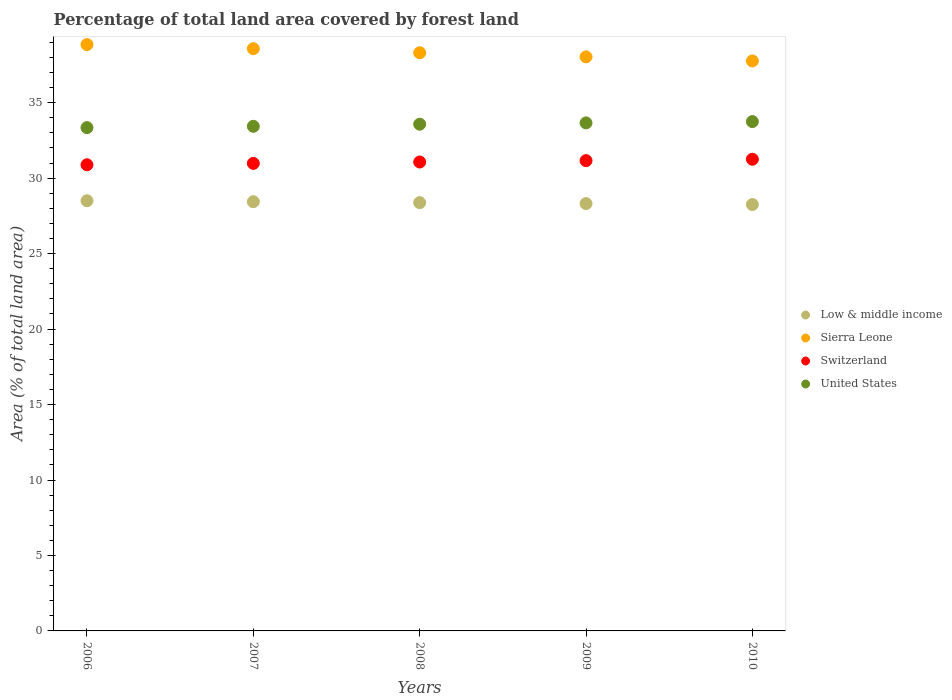How many different coloured dotlines are there?
Provide a succinct answer. 4. Is the number of dotlines equal to the number of legend labels?
Offer a terse response. Yes. What is the percentage of forest land in United States in 2009?
Your answer should be compact. 33.66. Across all years, what is the maximum percentage of forest land in Switzerland?
Your answer should be compact. 31.25. Across all years, what is the minimum percentage of forest land in Sierra Leone?
Provide a succinct answer. 37.77. In which year was the percentage of forest land in Sierra Leone maximum?
Your answer should be compact. 2006. What is the total percentage of forest land in Low & middle income in the graph?
Offer a terse response. 141.89. What is the difference between the percentage of forest land in Sierra Leone in 2007 and that in 2010?
Provide a short and direct response. 0.81. What is the difference between the percentage of forest land in Low & middle income in 2006 and the percentage of forest land in United States in 2007?
Your response must be concise. -4.93. What is the average percentage of forest land in United States per year?
Your response must be concise. 33.55. In the year 2009, what is the difference between the percentage of forest land in Switzerland and percentage of forest land in Sierra Leone?
Your response must be concise. -6.88. What is the ratio of the percentage of forest land in United States in 2009 to that in 2010?
Your answer should be compact. 1. Is the percentage of forest land in Low & middle income in 2007 less than that in 2008?
Your response must be concise. No. Is the difference between the percentage of forest land in Switzerland in 2007 and 2009 greater than the difference between the percentage of forest land in Sierra Leone in 2007 and 2009?
Keep it short and to the point. No. What is the difference between the highest and the second highest percentage of forest land in Switzerland?
Your response must be concise. 0.09. What is the difference between the highest and the lowest percentage of forest land in Sierra Leone?
Provide a short and direct response. 1.09. In how many years, is the percentage of forest land in United States greater than the average percentage of forest land in United States taken over all years?
Keep it short and to the point. 3. Is it the case that in every year, the sum of the percentage of forest land in Sierra Leone and percentage of forest land in United States  is greater than the sum of percentage of forest land in Low & middle income and percentage of forest land in Switzerland?
Make the answer very short. No. Is it the case that in every year, the sum of the percentage of forest land in Low & middle income and percentage of forest land in Switzerland  is greater than the percentage of forest land in United States?
Provide a succinct answer. Yes. Is the percentage of forest land in Low & middle income strictly less than the percentage of forest land in Switzerland over the years?
Offer a terse response. Yes. How many dotlines are there?
Give a very brief answer. 4. How many years are there in the graph?
Your response must be concise. 5. What is the difference between two consecutive major ticks on the Y-axis?
Make the answer very short. 5. Does the graph contain grids?
Give a very brief answer. No. How many legend labels are there?
Provide a short and direct response. 4. How are the legend labels stacked?
Your response must be concise. Vertical. What is the title of the graph?
Your answer should be compact. Percentage of total land area covered by forest land. What is the label or title of the Y-axis?
Ensure brevity in your answer.  Area (% of total land area). What is the Area (% of total land area) of Low & middle income in 2006?
Offer a very short reply. 28.5. What is the Area (% of total land area) in Sierra Leone in 2006?
Keep it short and to the point. 38.85. What is the Area (% of total land area) in Switzerland in 2006?
Give a very brief answer. 30.89. What is the Area (% of total land area) in United States in 2006?
Keep it short and to the point. 33.35. What is the Area (% of total land area) in Low & middle income in 2007?
Give a very brief answer. 28.44. What is the Area (% of total land area) of Sierra Leone in 2007?
Make the answer very short. 38.58. What is the Area (% of total land area) in Switzerland in 2007?
Offer a terse response. 30.98. What is the Area (% of total land area) of United States in 2007?
Provide a succinct answer. 33.44. What is the Area (% of total land area) of Low & middle income in 2008?
Ensure brevity in your answer.  28.38. What is the Area (% of total land area) of Sierra Leone in 2008?
Your response must be concise. 38.31. What is the Area (% of total land area) of Switzerland in 2008?
Make the answer very short. 31.07. What is the Area (% of total land area) of United States in 2008?
Keep it short and to the point. 33.58. What is the Area (% of total land area) of Low & middle income in 2009?
Your answer should be very brief. 28.32. What is the Area (% of total land area) of Sierra Leone in 2009?
Offer a terse response. 38.04. What is the Area (% of total land area) of Switzerland in 2009?
Ensure brevity in your answer.  31.16. What is the Area (% of total land area) in United States in 2009?
Ensure brevity in your answer.  33.66. What is the Area (% of total land area) in Low & middle income in 2010?
Your answer should be very brief. 28.25. What is the Area (% of total land area) of Sierra Leone in 2010?
Your answer should be compact. 37.77. What is the Area (% of total land area) of Switzerland in 2010?
Offer a very short reply. 31.25. What is the Area (% of total land area) of United States in 2010?
Ensure brevity in your answer.  33.75. Across all years, what is the maximum Area (% of total land area) in Low & middle income?
Offer a very short reply. 28.5. Across all years, what is the maximum Area (% of total land area) in Sierra Leone?
Your response must be concise. 38.85. Across all years, what is the maximum Area (% of total land area) of Switzerland?
Give a very brief answer. 31.25. Across all years, what is the maximum Area (% of total land area) of United States?
Your answer should be very brief. 33.75. Across all years, what is the minimum Area (% of total land area) in Low & middle income?
Offer a terse response. 28.25. Across all years, what is the minimum Area (% of total land area) in Sierra Leone?
Your answer should be very brief. 37.77. Across all years, what is the minimum Area (% of total land area) in Switzerland?
Your answer should be compact. 30.89. Across all years, what is the minimum Area (% of total land area) of United States?
Ensure brevity in your answer.  33.35. What is the total Area (% of total land area) in Low & middle income in the graph?
Provide a succinct answer. 141.89. What is the total Area (% of total land area) in Sierra Leone in the graph?
Provide a short and direct response. 191.55. What is the total Area (% of total land area) in Switzerland in the graph?
Keep it short and to the point. 155.35. What is the total Area (% of total land area) in United States in the graph?
Offer a terse response. 167.77. What is the difference between the Area (% of total land area) in Low & middle income in 2006 and that in 2007?
Keep it short and to the point. 0.06. What is the difference between the Area (% of total land area) in Sierra Leone in 2006 and that in 2007?
Provide a succinct answer. 0.27. What is the difference between the Area (% of total land area) in Switzerland in 2006 and that in 2007?
Offer a very short reply. -0.09. What is the difference between the Area (% of total land area) of United States in 2006 and that in 2007?
Provide a short and direct response. -0.09. What is the difference between the Area (% of total land area) of Low & middle income in 2006 and that in 2008?
Your answer should be compact. 0.13. What is the difference between the Area (% of total land area) of Sierra Leone in 2006 and that in 2008?
Keep it short and to the point. 0.54. What is the difference between the Area (% of total land area) of Switzerland in 2006 and that in 2008?
Your answer should be compact. -0.18. What is the difference between the Area (% of total land area) of United States in 2006 and that in 2008?
Your answer should be compact. -0.23. What is the difference between the Area (% of total land area) in Low & middle income in 2006 and that in 2009?
Ensure brevity in your answer.  0.19. What is the difference between the Area (% of total land area) of Sierra Leone in 2006 and that in 2009?
Give a very brief answer. 0.81. What is the difference between the Area (% of total land area) of Switzerland in 2006 and that in 2009?
Make the answer very short. -0.27. What is the difference between the Area (% of total land area) in United States in 2006 and that in 2009?
Make the answer very short. -0.31. What is the difference between the Area (% of total land area) in Low & middle income in 2006 and that in 2010?
Make the answer very short. 0.25. What is the difference between the Area (% of total land area) of Sierra Leone in 2006 and that in 2010?
Provide a short and direct response. 1.09. What is the difference between the Area (% of total land area) of Switzerland in 2006 and that in 2010?
Make the answer very short. -0.37. What is the difference between the Area (% of total land area) in United States in 2006 and that in 2010?
Your response must be concise. -0.4. What is the difference between the Area (% of total land area) of Low & middle income in 2007 and that in 2008?
Provide a succinct answer. 0.06. What is the difference between the Area (% of total land area) of Sierra Leone in 2007 and that in 2008?
Provide a succinct answer. 0.27. What is the difference between the Area (% of total land area) of Switzerland in 2007 and that in 2008?
Make the answer very short. -0.09. What is the difference between the Area (% of total land area) of United States in 2007 and that in 2008?
Your answer should be very brief. -0.14. What is the difference between the Area (% of total land area) of Low & middle income in 2007 and that in 2009?
Your answer should be very brief. 0.12. What is the difference between the Area (% of total land area) in Sierra Leone in 2007 and that in 2009?
Give a very brief answer. 0.54. What is the difference between the Area (% of total land area) in Switzerland in 2007 and that in 2009?
Keep it short and to the point. -0.18. What is the difference between the Area (% of total land area) of United States in 2007 and that in 2009?
Provide a short and direct response. -0.23. What is the difference between the Area (% of total land area) in Low & middle income in 2007 and that in 2010?
Your answer should be compact. 0.19. What is the difference between the Area (% of total land area) of Sierra Leone in 2007 and that in 2010?
Ensure brevity in your answer.  0.81. What is the difference between the Area (% of total land area) in Switzerland in 2007 and that in 2010?
Your response must be concise. -0.27. What is the difference between the Area (% of total land area) of United States in 2007 and that in 2010?
Provide a short and direct response. -0.31. What is the difference between the Area (% of total land area) of Low & middle income in 2008 and that in 2009?
Make the answer very short. 0.06. What is the difference between the Area (% of total land area) in Sierra Leone in 2008 and that in 2009?
Keep it short and to the point. 0.27. What is the difference between the Area (% of total land area) of Switzerland in 2008 and that in 2009?
Ensure brevity in your answer.  -0.09. What is the difference between the Area (% of total land area) of United States in 2008 and that in 2009?
Offer a terse response. -0.09. What is the difference between the Area (% of total land area) of Low & middle income in 2008 and that in 2010?
Provide a succinct answer. 0.13. What is the difference between the Area (% of total land area) of Sierra Leone in 2008 and that in 2010?
Keep it short and to the point. 0.54. What is the difference between the Area (% of total land area) in Switzerland in 2008 and that in 2010?
Provide a short and direct response. -0.18. What is the difference between the Area (% of total land area) of United States in 2008 and that in 2010?
Provide a succinct answer. -0.17. What is the difference between the Area (% of total land area) in Low & middle income in 2009 and that in 2010?
Your response must be concise. 0.06. What is the difference between the Area (% of total land area) of Sierra Leone in 2009 and that in 2010?
Ensure brevity in your answer.  0.27. What is the difference between the Area (% of total land area) in Switzerland in 2009 and that in 2010?
Your answer should be compact. -0.09. What is the difference between the Area (% of total land area) of United States in 2009 and that in 2010?
Your answer should be compact. -0.09. What is the difference between the Area (% of total land area) of Low & middle income in 2006 and the Area (% of total land area) of Sierra Leone in 2007?
Ensure brevity in your answer.  -10.08. What is the difference between the Area (% of total land area) of Low & middle income in 2006 and the Area (% of total land area) of Switzerland in 2007?
Ensure brevity in your answer.  -2.48. What is the difference between the Area (% of total land area) in Low & middle income in 2006 and the Area (% of total land area) in United States in 2007?
Provide a short and direct response. -4.93. What is the difference between the Area (% of total land area) of Sierra Leone in 2006 and the Area (% of total land area) of Switzerland in 2007?
Provide a succinct answer. 7.87. What is the difference between the Area (% of total land area) of Sierra Leone in 2006 and the Area (% of total land area) of United States in 2007?
Make the answer very short. 5.42. What is the difference between the Area (% of total land area) of Switzerland in 2006 and the Area (% of total land area) of United States in 2007?
Keep it short and to the point. -2.55. What is the difference between the Area (% of total land area) in Low & middle income in 2006 and the Area (% of total land area) in Sierra Leone in 2008?
Offer a terse response. -9.81. What is the difference between the Area (% of total land area) of Low & middle income in 2006 and the Area (% of total land area) of Switzerland in 2008?
Provide a succinct answer. -2.57. What is the difference between the Area (% of total land area) of Low & middle income in 2006 and the Area (% of total land area) of United States in 2008?
Your answer should be very brief. -5.07. What is the difference between the Area (% of total land area) in Sierra Leone in 2006 and the Area (% of total land area) in Switzerland in 2008?
Provide a short and direct response. 7.78. What is the difference between the Area (% of total land area) of Sierra Leone in 2006 and the Area (% of total land area) of United States in 2008?
Ensure brevity in your answer.  5.28. What is the difference between the Area (% of total land area) of Switzerland in 2006 and the Area (% of total land area) of United States in 2008?
Keep it short and to the point. -2.69. What is the difference between the Area (% of total land area) in Low & middle income in 2006 and the Area (% of total land area) in Sierra Leone in 2009?
Your response must be concise. -9.53. What is the difference between the Area (% of total land area) of Low & middle income in 2006 and the Area (% of total land area) of Switzerland in 2009?
Your response must be concise. -2.66. What is the difference between the Area (% of total land area) of Low & middle income in 2006 and the Area (% of total land area) of United States in 2009?
Give a very brief answer. -5.16. What is the difference between the Area (% of total land area) of Sierra Leone in 2006 and the Area (% of total land area) of Switzerland in 2009?
Your response must be concise. 7.69. What is the difference between the Area (% of total land area) of Sierra Leone in 2006 and the Area (% of total land area) of United States in 2009?
Offer a terse response. 5.19. What is the difference between the Area (% of total land area) of Switzerland in 2006 and the Area (% of total land area) of United States in 2009?
Keep it short and to the point. -2.77. What is the difference between the Area (% of total land area) in Low & middle income in 2006 and the Area (% of total land area) in Sierra Leone in 2010?
Ensure brevity in your answer.  -9.26. What is the difference between the Area (% of total land area) of Low & middle income in 2006 and the Area (% of total land area) of Switzerland in 2010?
Ensure brevity in your answer.  -2.75. What is the difference between the Area (% of total land area) of Low & middle income in 2006 and the Area (% of total land area) of United States in 2010?
Provide a succinct answer. -5.25. What is the difference between the Area (% of total land area) of Sierra Leone in 2006 and the Area (% of total land area) of Switzerland in 2010?
Your response must be concise. 7.6. What is the difference between the Area (% of total land area) in Sierra Leone in 2006 and the Area (% of total land area) in United States in 2010?
Your answer should be compact. 5.1. What is the difference between the Area (% of total land area) of Switzerland in 2006 and the Area (% of total land area) of United States in 2010?
Keep it short and to the point. -2.86. What is the difference between the Area (% of total land area) of Low & middle income in 2007 and the Area (% of total land area) of Sierra Leone in 2008?
Your answer should be compact. -9.87. What is the difference between the Area (% of total land area) in Low & middle income in 2007 and the Area (% of total land area) in Switzerland in 2008?
Ensure brevity in your answer.  -2.63. What is the difference between the Area (% of total land area) in Low & middle income in 2007 and the Area (% of total land area) in United States in 2008?
Your answer should be very brief. -5.13. What is the difference between the Area (% of total land area) in Sierra Leone in 2007 and the Area (% of total land area) in Switzerland in 2008?
Your response must be concise. 7.51. What is the difference between the Area (% of total land area) of Sierra Leone in 2007 and the Area (% of total land area) of United States in 2008?
Provide a succinct answer. 5.01. What is the difference between the Area (% of total land area) in Switzerland in 2007 and the Area (% of total land area) in United States in 2008?
Your response must be concise. -2.6. What is the difference between the Area (% of total land area) in Low & middle income in 2007 and the Area (% of total land area) in Sierra Leone in 2009?
Offer a very short reply. -9.6. What is the difference between the Area (% of total land area) in Low & middle income in 2007 and the Area (% of total land area) in Switzerland in 2009?
Make the answer very short. -2.72. What is the difference between the Area (% of total land area) of Low & middle income in 2007 and the Area (% of total land area) of United States in 2009?
Give a very brief answer. -5.22. What is the difference between the Area (% of total land area) of Sierra Leone in 2007 and the Area (% of total land area) of Switzerland in 2009?
Offer a terse response. 7.42. What is the difference between the Area (% of total land area) in Sierra Leone in 2007 and the Area (% of total land area) in United States in 2009?
Offer a very short reply. 4.92. What is the difference between the Area (% of total land area) of Switzerland in 2007 and the Area (% of total land area) of United States in 2009?
Your answer should be compact. -2.68. What is the difference between the Area (% of total land area) in Low & middle income in 2007 and the Area (% of total land area) in Sierra Leone in 2010?
Offer a very short reply. -9.33. What is the difference between the Area (% of total land area) in Low & middle income in 2007 and the Area (% of total land area) in Switzerland in 2010?
Provide a short and direct response. -2.81. What is the difference between the Area (% of total land area) in Low & middle income in 2007 and the Area (% of total land area) in United States in 2010?
Give a very brief answer. -5.31. What is the difference between the Area (% of total land area) of Sierra Leone in 2007 and the Area (% of total land area) of Switzerland in 2010?
Offer a very short reply. 7.33. What is the difference between the Area (% of total land area) of Sierra Leone in 2007 and the Area (% of total land area) of United States in 2010?
Provide a short and direct response. 4.83. What is the difference between the Area (% of total land area) of Switzerland in 2007 and the Area (% of total land area) of United States in 2010?
Provide a short and direct response. -2.77. What is the difference between the Area (% of total land area) in Low & middle income in 2008 and the Area (% of total land area) in Sierra Leone in 2009?
Give a very brief answer. -9.66. What is the difference between the Area (% of total land area) in Low & middle income in 2008 and the Area (% of total land area) in Switzerland in 2009?
Your answer should be compact. -2.78. What is the difference between the Area (% of total land area) of Low & middle income in 2008 and the Area (% of total land area) of United States in 2009?
Make the answer very short. -5.28. What is the difference between the Area (% of total land area) in Sierra Leone in 2008 and the Area (% of total land area) in Switzerland in 2009?
Offer a terse response. 7.15. What is the difference between the Area (% of total land area) in Sierra Leone in 2008 and the Area (% of total land area) in United States in 2009?
Keep it short and to the point. 4.65. What is the difference between the Area (% of total land area) in Switzerland in 2008 and the Area (% of total land area) in United States in 2009?
Your response must be concise. -2.59. What is the difference between the Area (% of total land area) of Low & middle income in 2008 and the Area (% of total land area) of Sierra Leone in 2010?
Provide a succinct answer. -9.39. What is the difference between the Area (% of total land area) in Low & middle income in 2008 and the Area (% of total land area) in Switzerland in 2010?
Provide a short and direct response. -2.87. What is the difference between the Area (% of total land area) of Low & middle income in 2008 and the Area (% of total land area) of United States in 2010?
Your answer should be very brief. -5.37. What is the difference between the Area (% of total land area) in Sierra Leone in 2008 and the Area (% of total land area) in Switzerland in 2010?
Your answer should be compact. 7.06. What is the difference between the Area (% of total land area) of Sierra Leone in 2008 and the Area (% of total land area) of United States in 2010?
Provide a short and direct response. 4.56. What is the difference between the Area (% of total land area) of Switzerland in 2008 and the Area (% of total land area) of United States in 2010?
Offer a very short reply. -2.68. What is the difference between the Area (% of total land area) of Low & middle income in 2009 and the Area (% of total land area) of Sierra Leone in 2010?
Your answer should be very brief. -9.45. What is the difference between the Area (% of total land area) in Low & middle income in 2009 and the Area (% of total land area) in Switzerland in 2010?
Offer a terse response. -2.94. What is the difference between the Area (% of total land area) of Low & middle income in 2009 and the Area (% of total land area) of United States in 2010?
Offer a very short reply. -5.43. What is the difference between the Area (% of total land area) of Sierra Leone in 2009 and the Area (% of total land area) of Switzerland in 2010?
Keep it short and to the point. 6.79. What is the difference between the Area (% of total land area) in Sierra Leone in 2009 and the Area (% of total land area) in United States in 2010?
Your answer should be very brief. 4.29. What is the difference between the Area (% of total land area) of Switzerland in 2009 and the Area (% of total land area) of United States in 2010?
Give a very brief answer. -2.59. What is the average Area (% of total land area) in Low & middle income per year?
Provide a succinct answer. 28.38. What is the average Area (% of total land area) in Sierra Leone per year?
Ensure brevity in your answer.  38.31. What is the average Area (% of total land area) of Switzerland per year?
Your response must be concise. 31.07. What is the average Area (% of total land area) of United States per year?
Your answer should be compact. 33.55. In the year 2006, what is the difference between the Area (% of total land area) of Low & middle income and Area (% of total land area) of Sierra Leone?
Give a very brief answer. -10.35. In the year 2006, what is the difference between the Area (% of total land area) in Low & middle income and Area (% of total land area) in Switzerland?
Provide a short and direct response. -2.38. In the year 2006, what is the difference between the Area (% of total land area) of Low & middle income and Area (% of total land area) of United States?
Your response must be concise. -4.85. In the year 2006, what is the difference between the Area (% of total land area) in Sierra Leone and Area (% of total land area) in Switzerland?
Offer a very short reply. 7.96. In the year 2006, what is the difference between the Area (% of total land area) in Sierra Leone and Area (% of total land area) in United States?
Provide a short and direct response. 5.5. In the year 2006, what is the difference between the Area (% of total land area) in Switzerland and Area (% of total land area) in United States?
Provide a succinct answer. -2.46. In the year 2007, what is the difference between the Area (% of total land area) in Low & middle income and Area (% of total land area) in Sierra Leone?
Provide a short and direct response. -10.14. In the year 2007, what is the difference between the Area (% of total land area) of Low & middle income and Area (% of total land area) of Switzerland?
Ensure brevity in your answer.  -2.54. In the year 2007, what is the difference between the Area (% of total land area) in Low & middle income and Area (% of total land area) in United States?
Your answer should be very brief. -5. In the year 2007, what is the difference between the Area (% of total land area) of Sierra Leone and Area (% of total land area) of Switzerland?
Provide a short and direct response. 7.6. In the year 2007, what is the difference between the Area (% of total land area) in Sierra Leone and Area (% of total land area) in United States?
Offer a terse response. 5.14. In the year 2007, what is the difference between the Area (% of total land area) of Switzerland and Area (% of total land area) of United States?
Provide a short and direct response. -2.46. In the year 2008, what is the difference between the Area (% of total land area) of Low & middle income and Area (% of total land area) of Sierra Leone?
Keep it short and to the point. -9.93. In the year 2008, what is the difference between the Area (% of total land area) of Low & middle income and Area (% of total land area) of Switzerland?
Your answer should be very brief. -2.69. In the year 2008, what is the difference between the Area (% of total land area) in Low & middle income and Area (% of total land area) in United States?
Your response must be concise. -5.2. In the year 2008, what is the difference between the Area (% of total land area) of Sierra Leone and Area (% of total land area) of Switzerland?
Offer a terse response. 7.24. In the year 2008, what is the difference between the Area (% of total land area) in Sierra Leone and Area (% of total land area) in United States?
Make the answer very short. 4.73. In the year 2008, what is the difference between the Area (% of total land area) of Switzerland and Area (% of total land area) of United States?
Your response must be concise. -2.51. In the year 2009, what is the difference between the Area (% of total land area) in Low & middle income and Area (% of total land area) in Sierra Leone?
Your response must be concise. -9.72. In the year 2009, what is the difference between the Area (% of total land area) in Low & middle income and Area (% of total land area) in Switzerland?
Your response must be concise. -2.85. In the year 2009, what is the difference between the Area (% of total land area) in Low & middle income and Area (% of total land area) in United States?
Keep it short and to the point. -5.35. In the year 2009, what is the difference between the Area (% of total land area) of Sierra Leone and Area (% of total land area) of Switzerland?
Offer a terse response. 6.88. In the year 2009, what is the difference between the Area (% of total land area) of Sierra Leone and Area (% of total land area) of United States?
Offer a very short reply. 4.38. In the year 2009, what is the difference between the Area (% of total land area) in Switzerland and Area (% of total land area) in United States?
Your answer should be compact. -2.5. In the year 2010, what is the difference between the Area (% of total land area) in Low & middle income and Area (% of total land area) in Sierra Leone?
Provide a short and direct response. -9.51. In the year 2010, what is the difference between the Area (% of total land area) of Low & middle income and Area (% of total land area) of Switzerland?
Provide a succinct answer. -3. In the year 2010, what is the difference between the Area (% of total land area) of Low & middle income and Area (% of total land area) of United States?
Provide a short and direct response. -5.5. In the year 2010, what is the difference between the Area (% of total land area) of Sierra Leone and Area (% of total land area) of Switzerland?
Your answer should be very brief. 6.51. In the year 2010, what is the difference between the Area (% of total land area) of Sierra Leone and Area (% of total land area) of United States?
Provide a succinct answer. 4.02. In the year 2010, what is the difference between the Area (% of total land area) in Switzerland and Area (% of total land area) in United States?
Keep it short and to the point. -2.5. What is the ratio of the Area (% of total land area) of Low & middle income in 2006 to that in 2007?
Keep it short and to the point. 1. What is the ratio of the Area (% of total land area) of Low & middle income in 2006 to that in 2008?
Your answer should be very brief. 1. What is the ratio of the Area (% of total land area) of Sierra Leone in 2006 to that in 2008?
Keep it short and to the point. 1.01. What is the ratio of the Area (% of total land area) in United States in 2006 to that in 2008?
Make the answer very short. 0.99. What is the ratio of the Area (% of total land area) in Low & middle income in 2006 to that in 2009?
Provide a short and direct response. 1.01. What is the ratio of the Area (% of total land area) in Sierra Leone in 2006 to that in 2009?
Offer a very short reply. 1.02. What is the ratio of the Area (% of total land area) of United States in 2006 to that in 2009?
Keep it short and to the point. 0.99. What is the ratio of the Area (% of total land area) in Low & middle income in 2006 to that in 2010?
Your answer should be compact. 1.01. What is the ratio of the Area (% of total land area) of Sierra Leone in 2006 to that in 2010?
Provide a short and direct response. 1.03. What is the ratio of the Area (% of total land area) of Switzerland in 2006 to that in 2010?
Give a very brief answer. 0.99. What is the ratio of the Area (% of total land area) of Sierra Leone in 2007 to that in 2008?
Offer a terse response. 1.01. What is the ratio of the Area (% of total land area) in Low & middle income in 2007 to that in 2009?
Provide a succinct answer. 1. What is the ratio of the Area (% of total land area) in Sierra Leone in 2007 to that in 2009?
Your answer should be very brief. 1.01. What is the ratio of the Area (% of total land area) of Switzerland in 2007 to that in 2009?
Give a very brief answer. 0.99. What is the ratio of the Area (% of total land area) of Low & middle income in 2007 to that in 2010?
Give a very brief answer. 1.01. What is the ratio of the Area (% of total land area) in Sierra Leone in 2007 to that in 2010?
Offer a very short reply. 1.02. What is the ratio of the Area (% of total land area) in Switzerland in 2007 to that in 2010?
Provide a short and direct response. 0.99. What is the ratio of the Area (% of total land area) of United States in 2007 to that in 2010?
Give a very brief answer. 0.99. What is the ratio of the Area (% of total land area) of Low & middle income in 2008 to that in 2009?
Provide a short and direct response. 1. What is the ratio of the Area (% of total land area) of Sierra Leone in 2008 to that in 2009?
Offer a terse response. 1.01. What is the ratio of the Area (% of total land area) in Switzerland in 2008 to that in 2009?
Ensure brevity in your answer.  1. What is the ratio of the Area (% of total land area) of United States in 2008 to that in 2009?
Provide a short and direct response. 1. What is the ratio of the Area (% of total land area) in Sierra Leone in 2008 to that in 2010?
Ensure brevity in your answer.  1.01. What is the ratio of the Area (% of total land area) in United States in 2008 to that in 2010?
Offer a very short reply. 0.99. What is the ratio of the Area (% of total land area) in Sierra Leone in 2009 to that in 2010?
Keep it short and to the point. 1.01. What is the ratio of the Area (% of total land area) in Switzerland in 2009 to that in 2010?
Offer a terse response. 1. What is the difference between the highest and the second highest Area (% of total land area) in Low & middle income?
Offer a very short reply. 0.06. What is the difference between the highest and the second highest Area (% of total land area) of Sierra Leone?
Offer a terse response. 0.27. What is the difference between the highest and the second highest Area (% of total land area) in Switzerland?
Ensure brevity in your answer.  0.09. What is the difference between the highest and the second highest Area (% of total land area) of United States?
Your response must be concise. 0.09. What is the difference between the highest and the lowest Area (% of total land area) in Low & middle income?
Make the answer very short. 0.25. What is the difference between the highest and the lowest Area (% of total land area) of Sierra Leone?
Make the answer very short. 1.09. What is the difference between the highest and the lowest Area (% of total land area) in Switzerland?
Ensure brevity in your answer.  0.37. What is the difference between the highest and the lowest Area (% of total land area) in United States?
Your answer should be very brief. 0.4. 